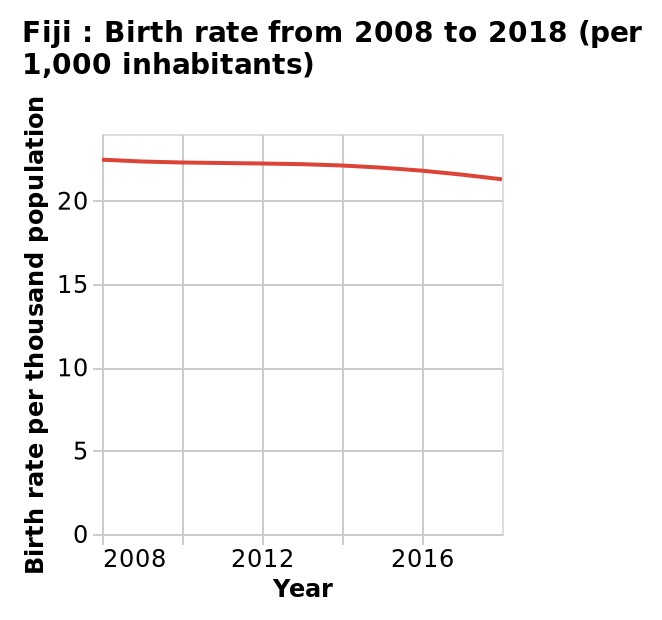<image>
When did the biggest decrease in birth rates occur? The biggest decrease in birth rates occurred between 2016 and 2018. please describe the details of the chart Here a is a line chart called Fiji : Birth rate from 2008 to 2018 (per 1,000 inhabitants). A linear scale of range 0 to 20 can be seen on the y-axis, labeled Birth rate per thousand population. There is a linear scale of range 2008 to 2016 along the x-axis, marked Year. 